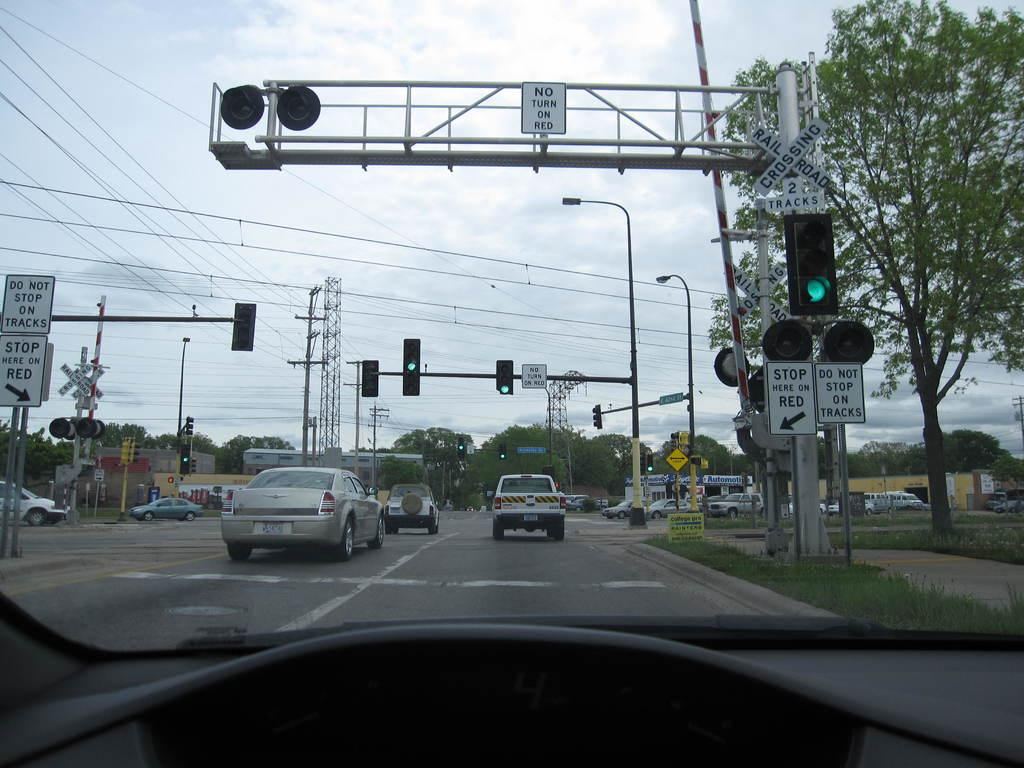<image>
Relay a brief, clear account of the picture shown. A car is driving past a traffic light and a train crossing sign says Do Not Stop On Tracks. 